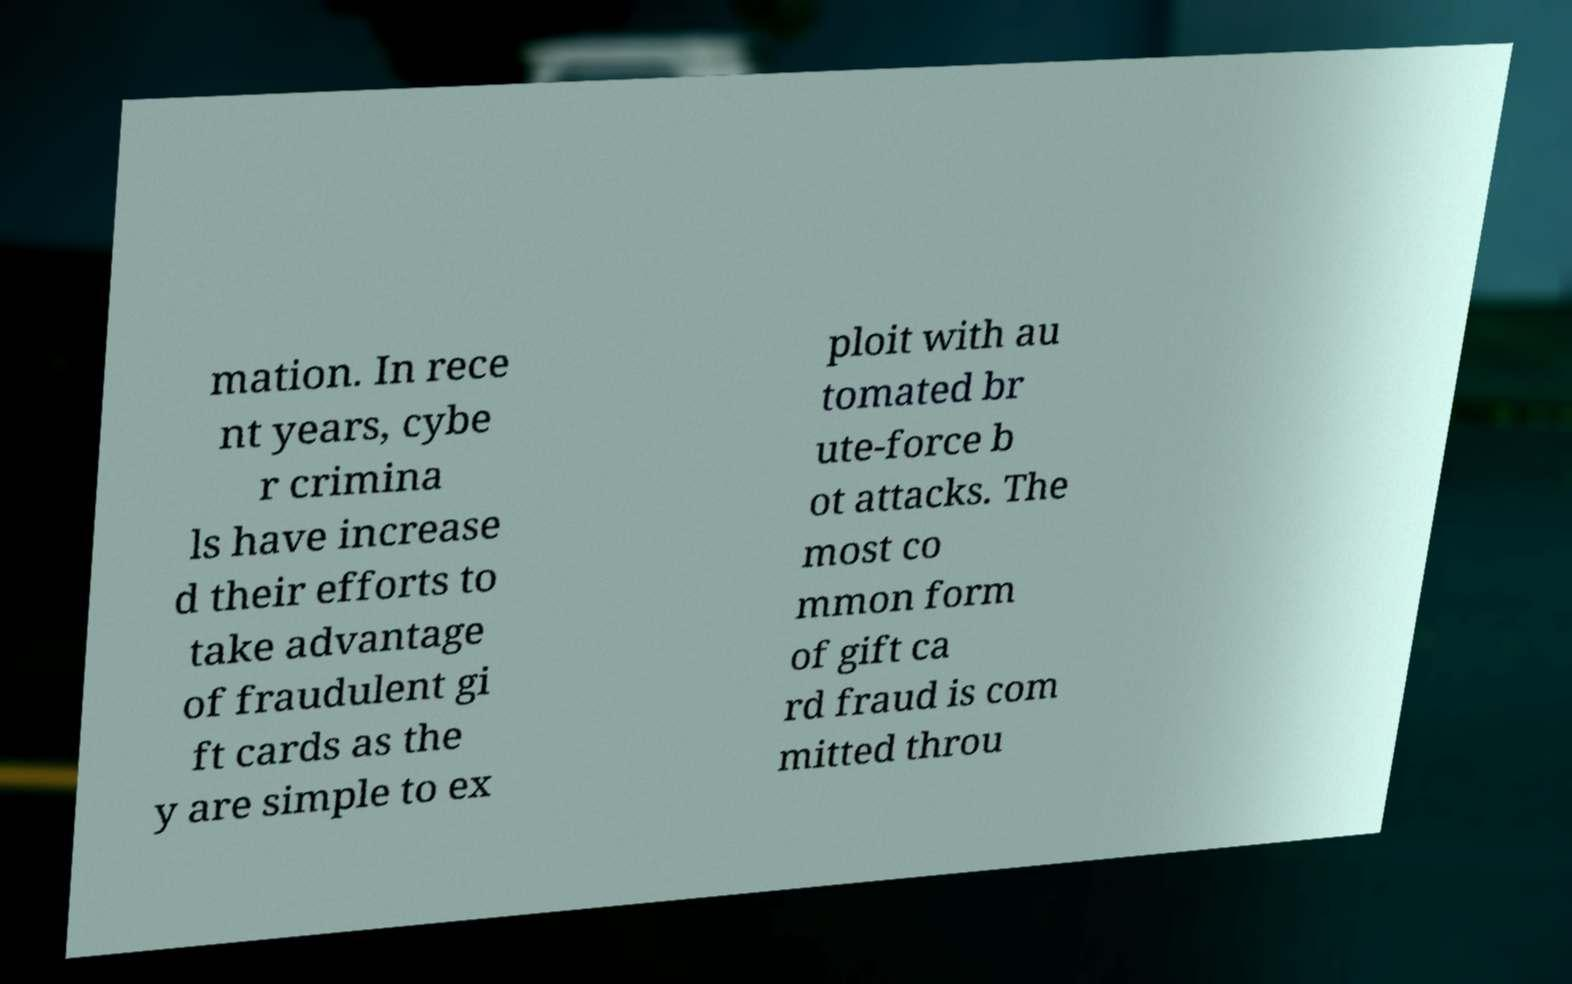Can you accurately transcribe the text from the provided image for me? mation. In rece nt years, cybe r crimina ls have increase d their efforts to take advantage of fraudulent gi ft cards as the y are simple to ex ploit with au tomated br ute-force b ot attacks. The most co mmon form of gift ca rd fraud is com mitted throu 